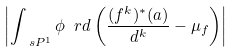<formula> <loc_0><loc_0><loc_500><loc_500>\left | \int _ { \ s P ^ { 1 } } \phi \ r d \left ( \frac { ( f ^ { k } ) ^ { * } ( a ) } { d ^ { k } } - \mu _ { f } \right ) \right |</formula> 